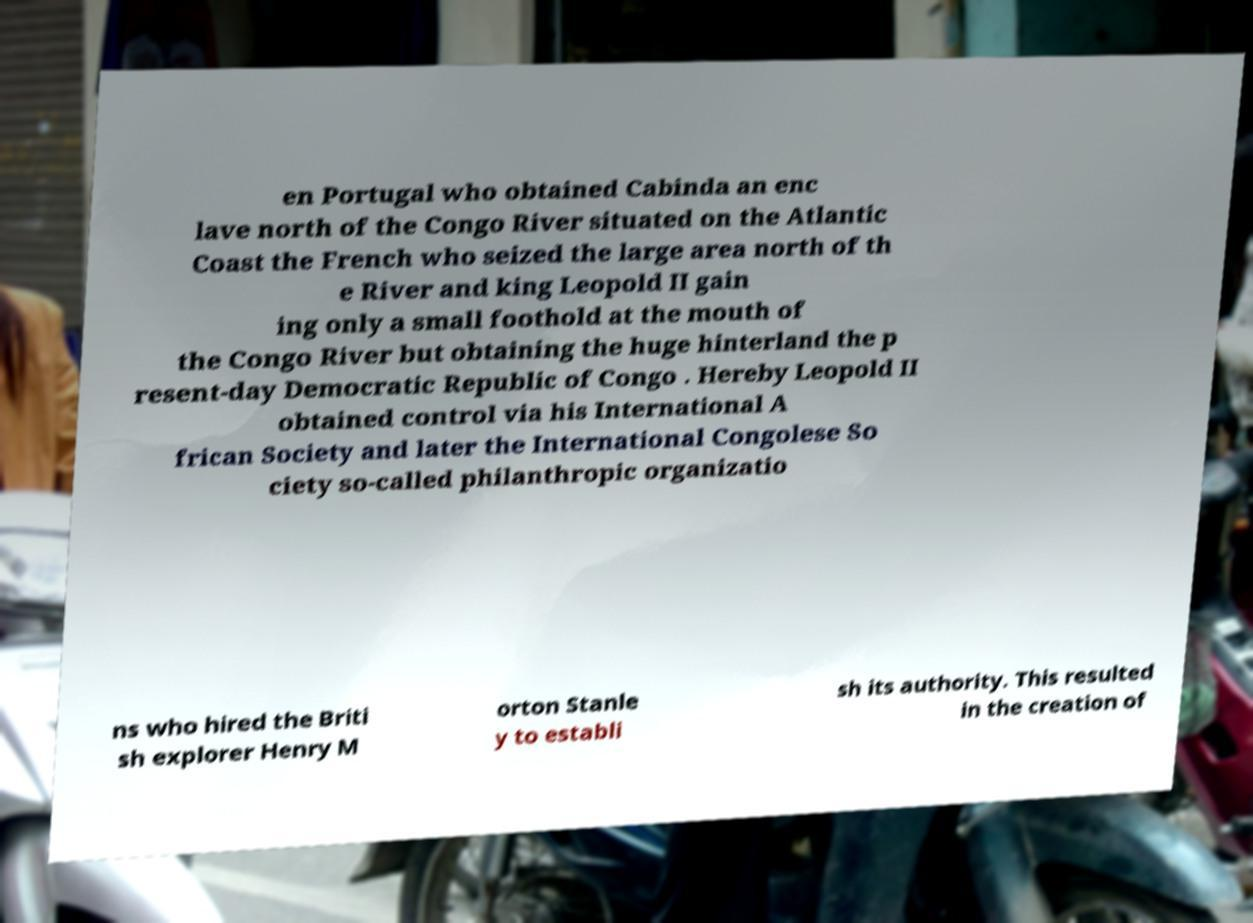Can you read and provide the text displayed in the image?This photo seems to have some interesting text. Can you extract and type it out for me? en Portugal who obtained Cabinda an enc lave north of the Congo River situated on the Atlantic Coast the French who seized the large area north of th e River and king Leopold II gain ing only a small foothold at the mouth of the Congo River but obtaining the huge hinterland the p resent-day Democratic Republic of Congo . Hereby Leopold II obtained control via his International A frican Society and later the International Congolese So ciety so-called philanthropic organizatio ns who hired the Briti sh explorer Henry M orton Stanle y to establi sh its authority. This resulted in the creation of 